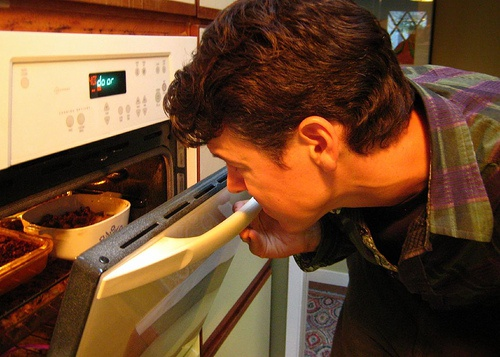Describe the objects in this image and their specific colors. I can see people in maroon, black, red, and olive tones, oven in maroon, khaki, black, and olive tones, and bowl in maroon, black, and orange tones in this image. 